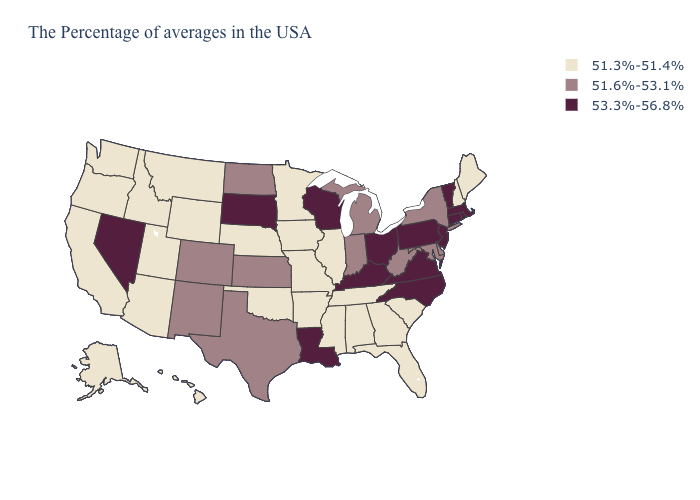What is the highest value in the West ?
Answer briefly. 53.3%-56.8%. Which states have the lowest value in the USA?
Keep it brief. Maine, New Hampshire, South Carolina, Florida, Georgia, Alabama, Tennessee, Illinois, Mississippi, Missouri, Arkansas, Minnesota, Iowa, Nebraska, Oklahoma, Wyoming, Utah, Montana, Arizona, Idaho, California, Washington, Oregon, Alaska, Hawaii. What is the value of Virginia?
Keep it brief. 53.3%-56.8%. Does Connecticut have the highest value in the Northeast?
Give a very brief answer. Yes. Does the map have missing data?
Write a very short answer. No. Which states have the lowest value in the USA?
Give a very brief answer. Maine, New Hampshire, South Carolina, Florida, Georgia, Alabama, Tennessee, Illinois, Mississippi, Missouri, Arkansas, Minnesota, Iowa, Nebraska, Oklahoma, Wyoming, Utah, Montana, Arizona, Idaho, California, Washington, Oregon, Alaska, Hawaii. Name the states that have a value in the range 51.6%-53.1%?
Give a very brief answer. New York, Delaware, Maryland, West Virginia, Michigan, Indiana, Kansas, Texas, North Dakota, Colorado, New Mexico. Name the states that have a value in the range 51.3%-51.4%?
Concise answer only. Maine, New Hampshire, South Carolina, Florida, Georgia, Alabama, Tennessee, Illinois, Mississippi, Missouri, Arkansas, Minnesota, Iowa, Nebraska, Oklahoma, Wyoming, Utah, Montana, Arizona, Idaho, California, Washington, Oregon, Alaska, Hawaii. Which states have the highest value in the USA?
Be succinct. Massachusetts, Rhode Island, Vermont, Connecticut, New Jersey, Pennsylvania, Virginia, North Carolina, Ohio, Kentucky, Wisconsin, Louisiana, South Dakota, Nevada. Which states have the lowest value in the South?
Write a very short answer. South Carolina, Florida, Georgia, Alabama, Tennessee, Mississippi, Arkansas, Oklahoma. Does Nevada have the lowest value in the West?
Give a very brief answer. No. Does Oklahoma have a lower value than Alaska?
Give a very brief answer. No. Is the legend a continuous bar?
Write a very short answer. No. What is the lowest value in states that border Maryland?
Short answer required. 51.6%-53.1%. Does the map have missing data?
Short answer required. No. 